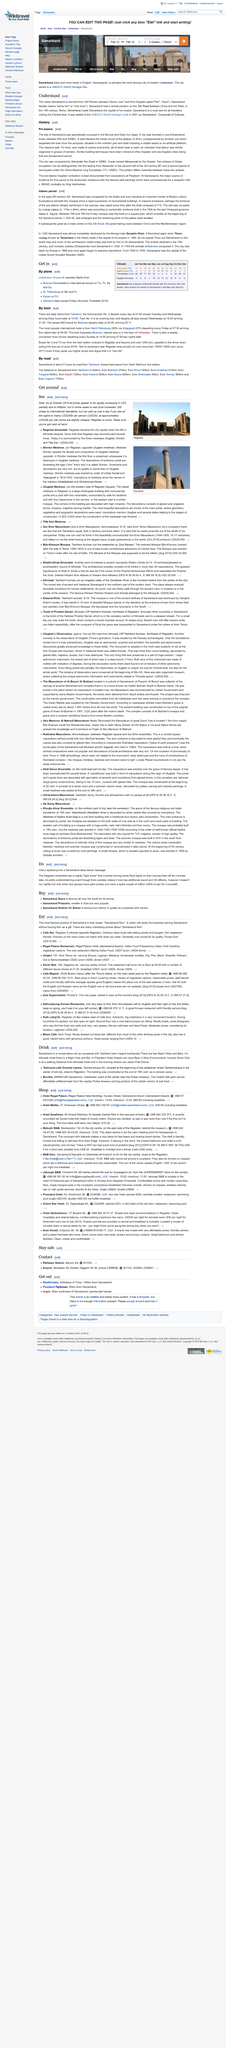Highlight a few significant elements in this photo. Yes, Registan has been reconstructed more than once. Registan became the city square when the life in Afrosiab stopped, marking the end of its former glory as the grandest city in Central Asia. The photograph shows Registan. 